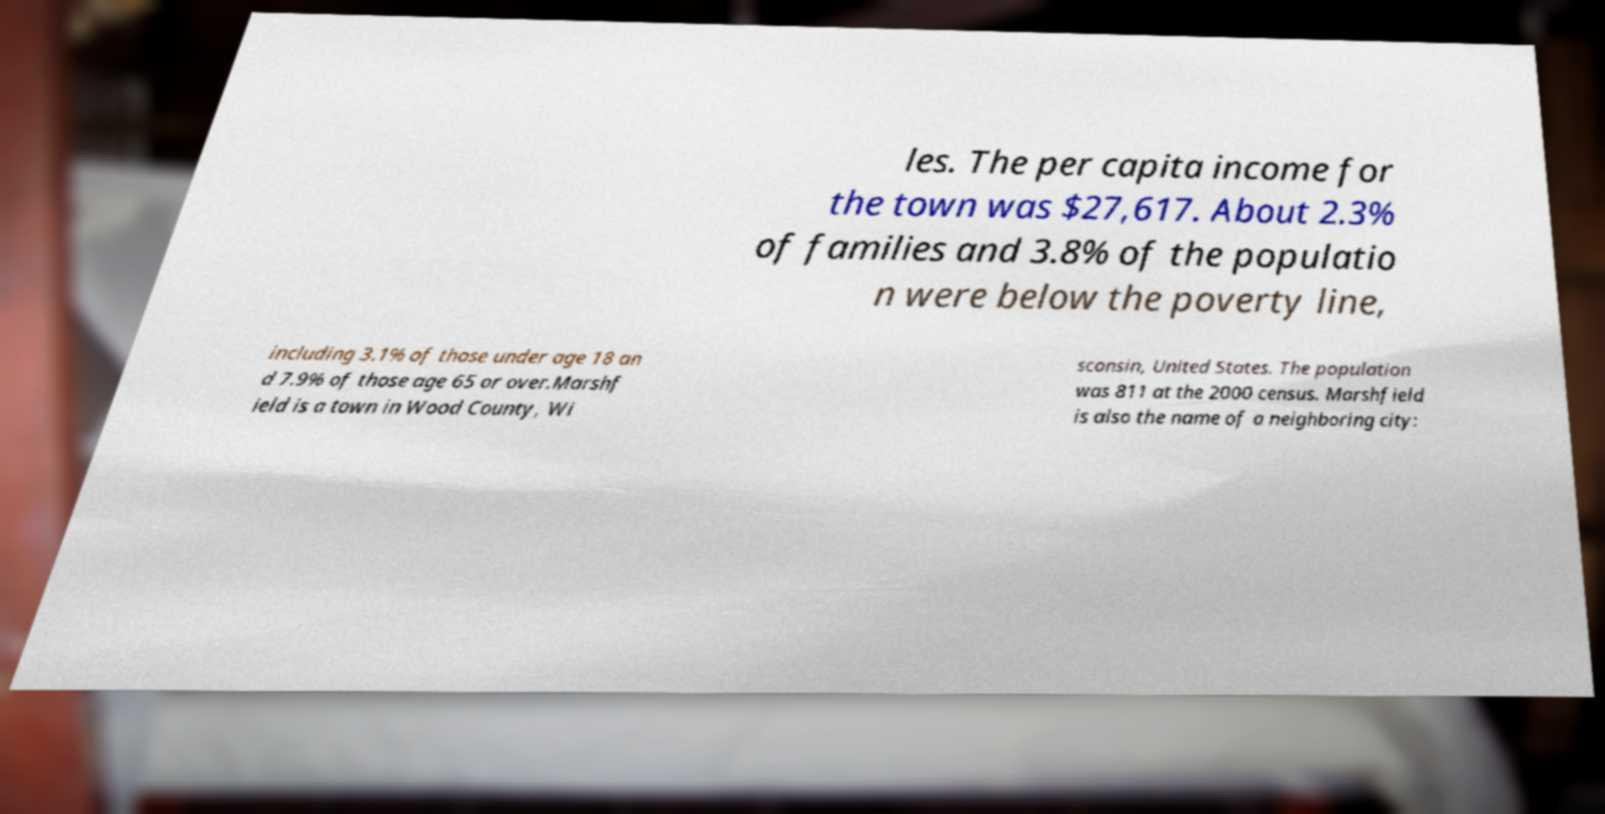Please identify and transcribe the text found in this image. les. The per capita income for the town was $27,617. About 2.3% of families and 3.8% of the populatio n were below the poverty line, including 3.1% of those under age 18 an d 7.9% of those age 65 or over.Marshf ield is a town in Wood County, Wi sconsin, United States. The population was 811 at the 2000 census. Marshfield is also the name of a neighboring city: 